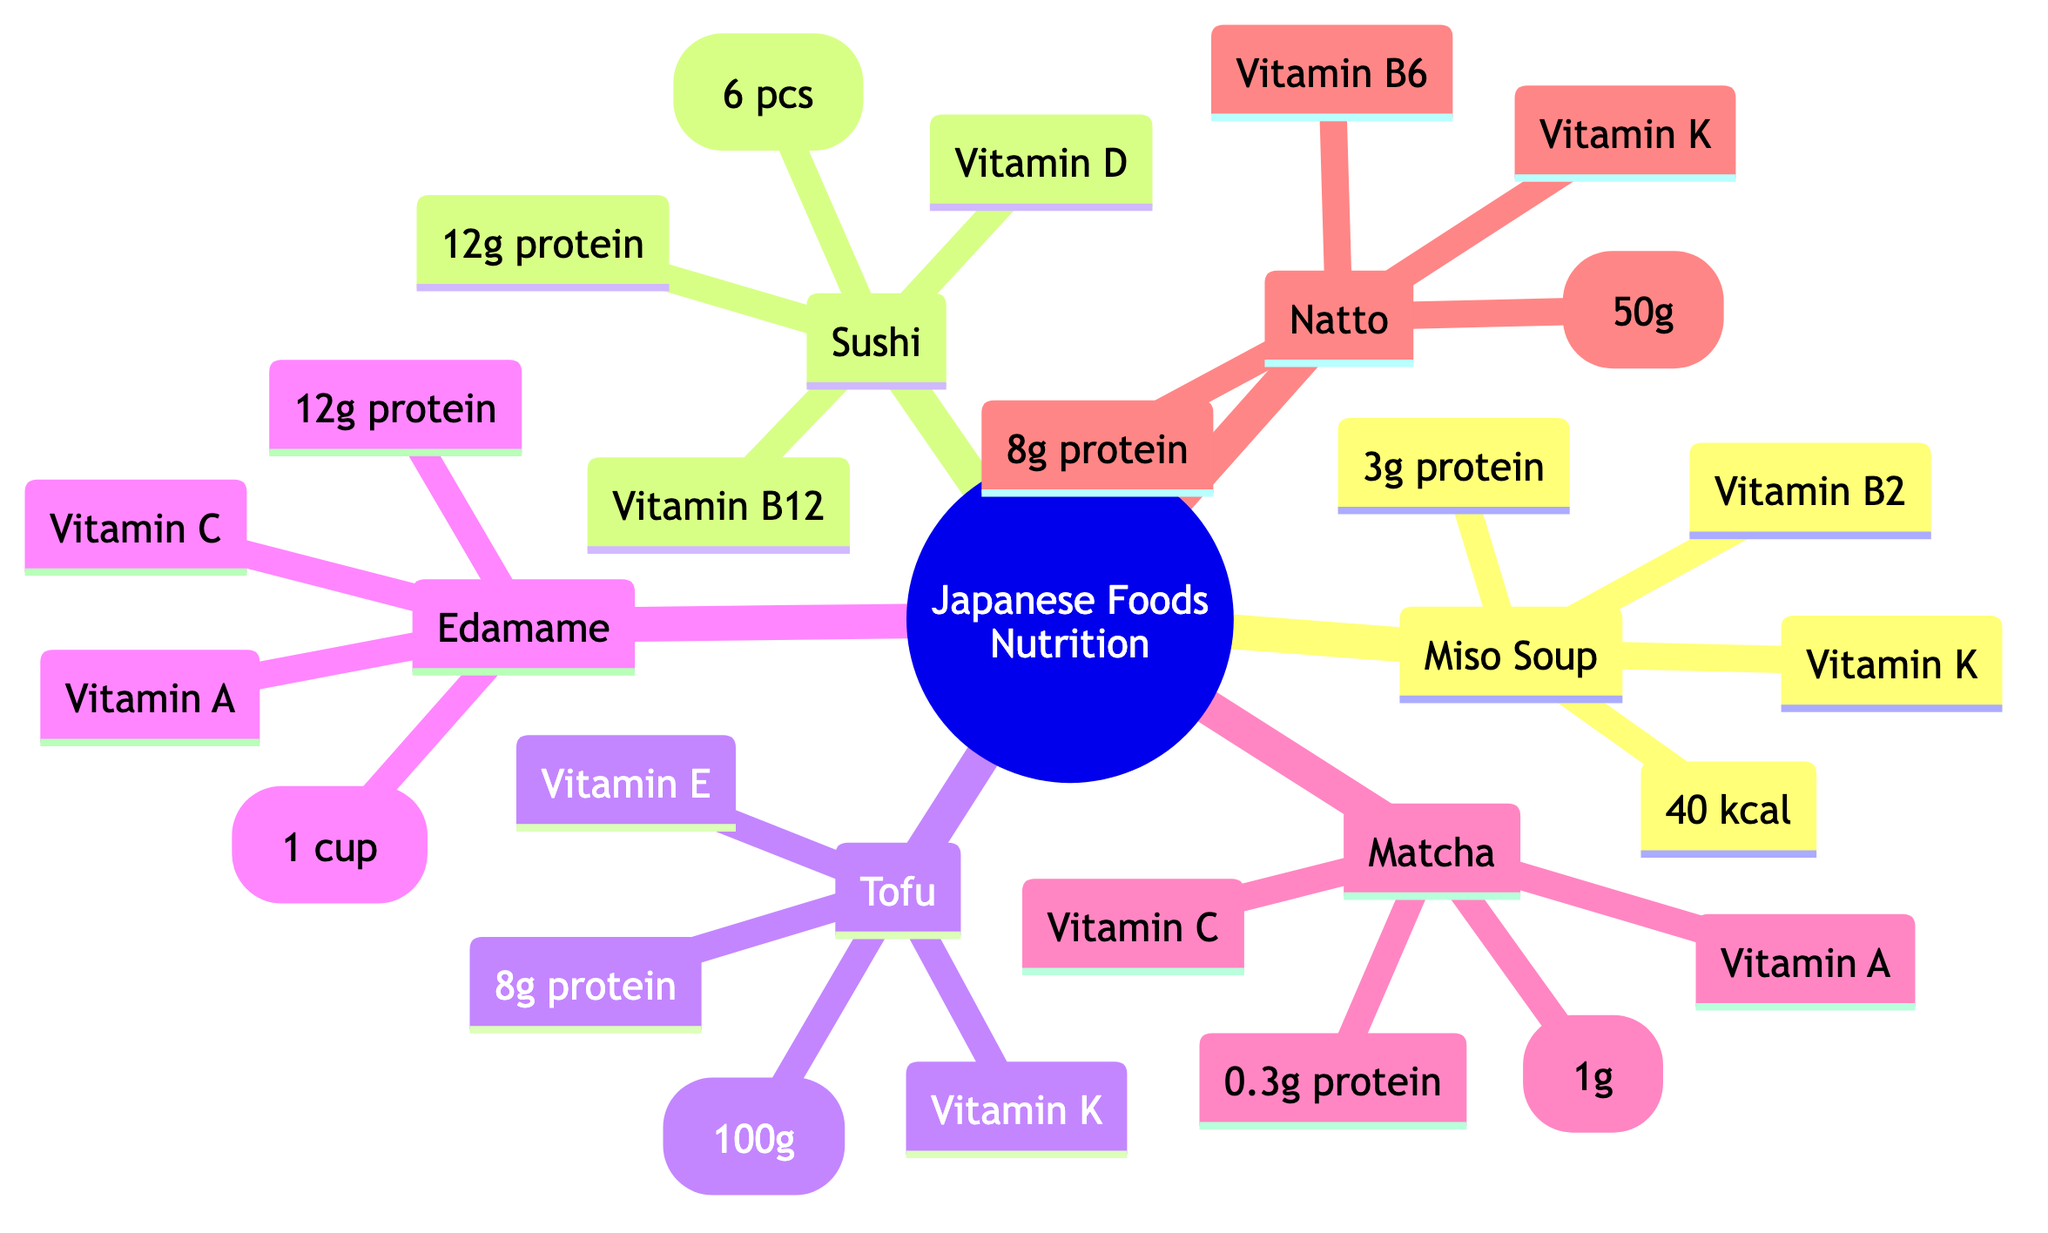What is the calorie count of Miso Soup? The diagram states that Miso Soup contains 40 kcal.
Answer: 40 kcal Which food item has the highest protein content? By comparing the protein values listed, Sushi and Edamame both have 12g protein, which is the highest among all items.
Answer: Sushi, Edamame How many vitamins are listed for Tofu? The diagram indicates that Tofu has two vitamins: Vitamin E and Vitamin K.
Answer: 2 What is the protein content of Matcha? According to the diagram, Matcha has 0.3g of protein listed.
Answer: 0.3g protein Which food has Vitamin C as one of its nutrients? The diagram shows that Edamame contains Vitamin C.
Answer: Edamame What is the total calorie content of Sushi? The total calorie content for Sushi is explicitly stated as 200 kcal for 6 pieces.
Answer: 200 kcal How many grams of protein does Natto provide? The diagram notes that Natto contains 8g of protein, as indicated in its nutritional information.
Answer: 8g protein Which two items share Vitamin K as a nutritional component? By reviewing the vitamins identified for Tofu and Natto, both contain Vitamin K, which is shared between them.
Answer: Tofu, Natto Which food item has the lowest calorie count? The diagram shows that Matcha has the lowest calorie count at 5 kcal.
Answer: 5 kcal 